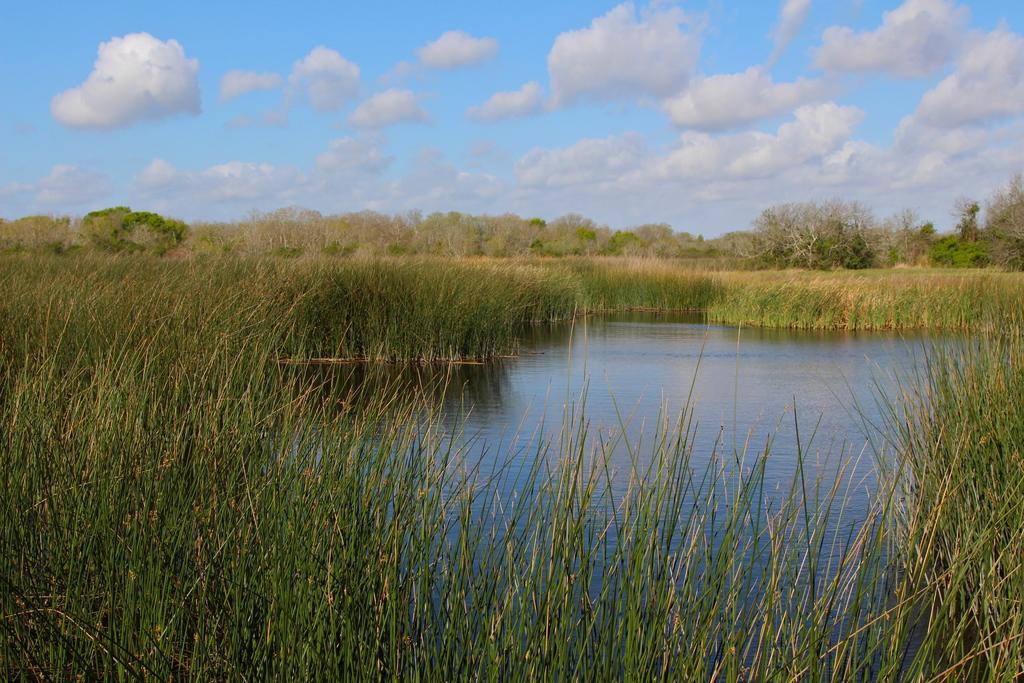Please provide a concise description of this image. In this image we can see the water and the grass. Behind the grass, we can see a group of trees. At the top we can see the sky. 